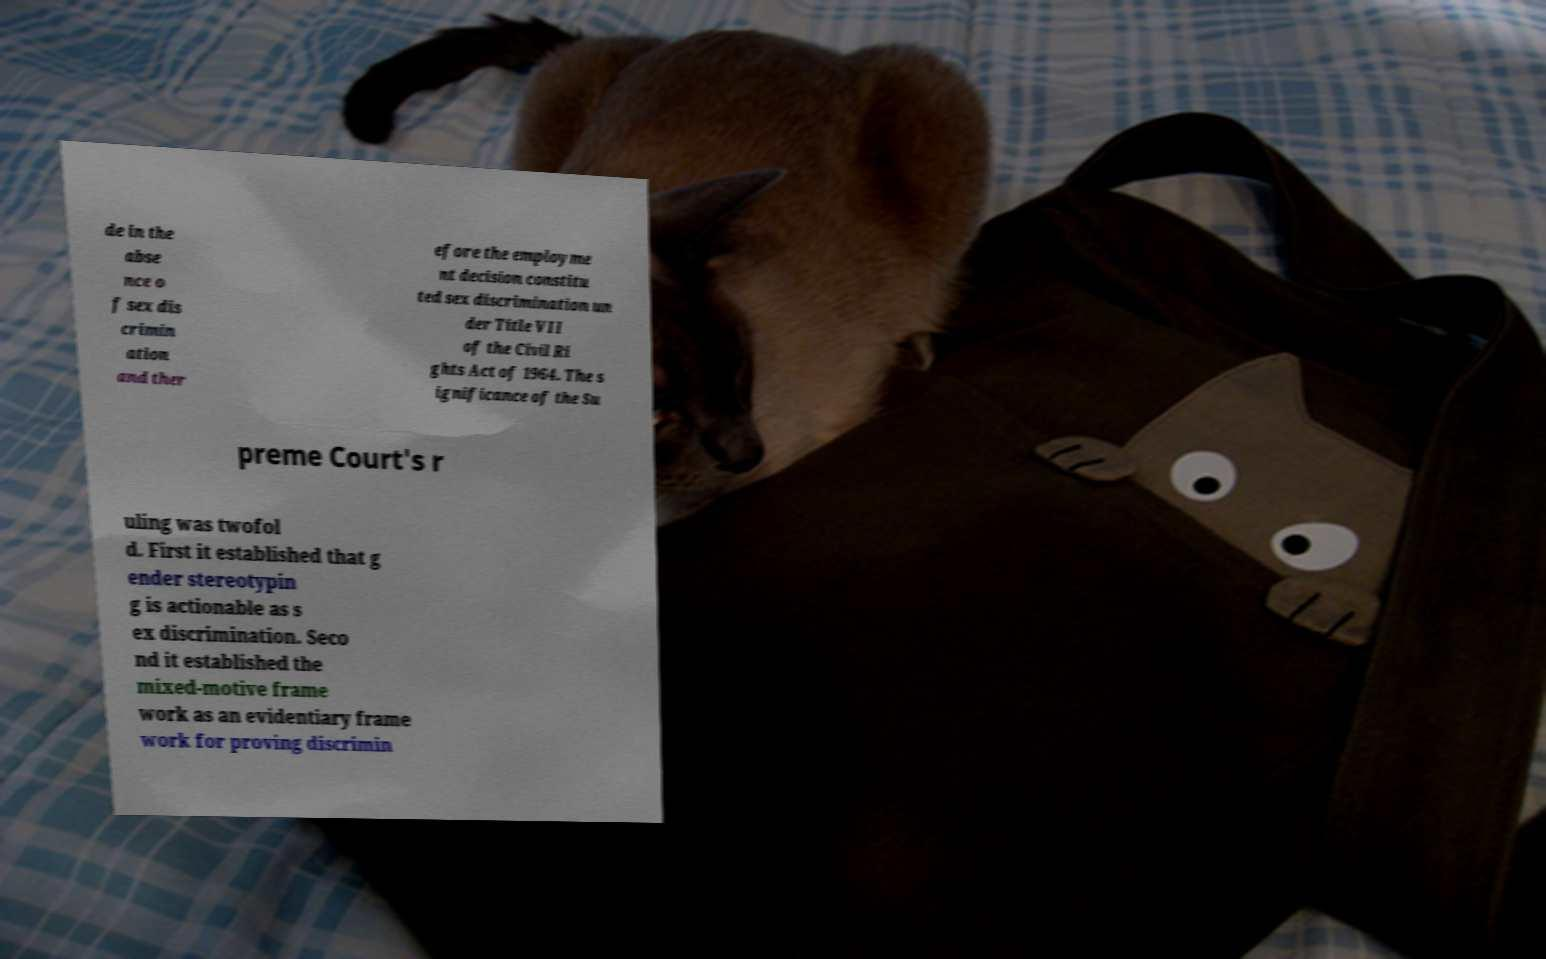Can you accurately transcribe the text from the provided image for me? de in the abse nce o f sex dis crimin ation and ther efore the employme nt decision constitu ted sex discrimination un der Title VII of the Civil Ri ghts Act of 1964. The s ignificance of the Su preme Court's r uling was twofol d. First it established that g ender stereotypin g is actionable as s ex discrimination. Seco nd it established the mixed-motive frame work as an evidentiary frame work for proving discrimin 